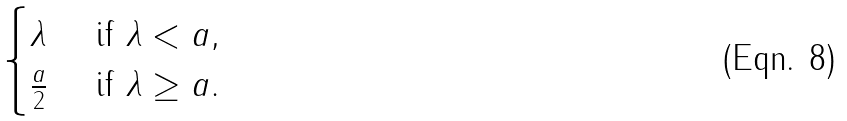Convert formula to latex. <formula><loc_0><loc_0><loc_500><loc_500>\begin{cases} \lambda & \text { if } \lambda < a , \\ \frac { a } { 2 } & \text { if } \lambda \geq a . \end{cases}</formula> 